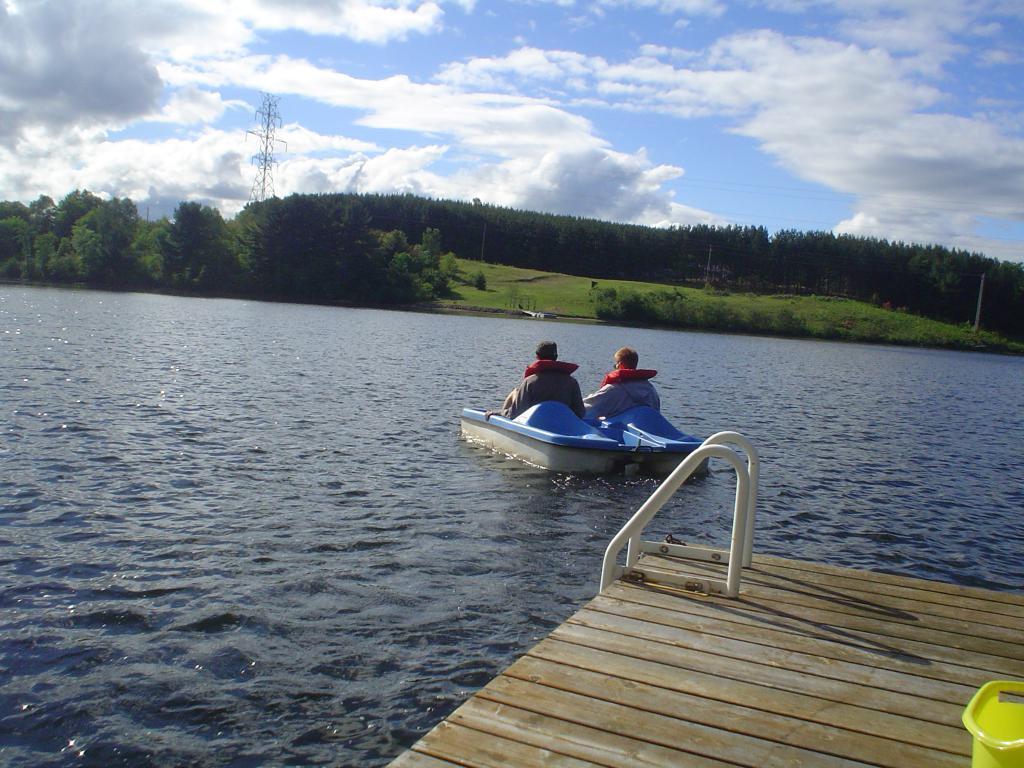In one or two sentences, can you explain what this image depicts? In this image, I can see two persons sitting on a boat, which is on the water. At the bottom of the image, I can see a wooden platform and It looks like a pool step ladder. In the background, there are trees, grass, a transmission tower and the sky. 